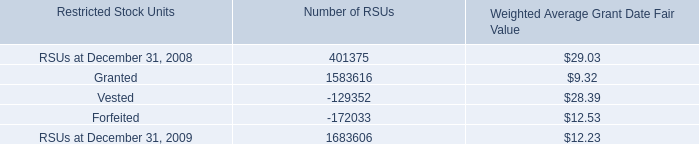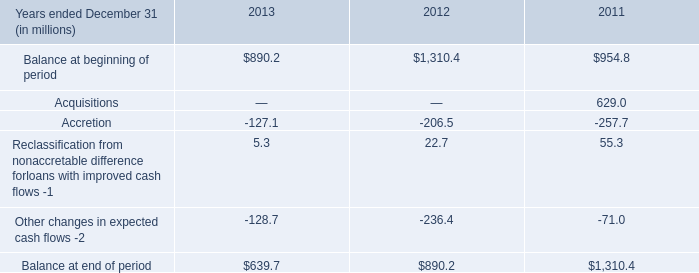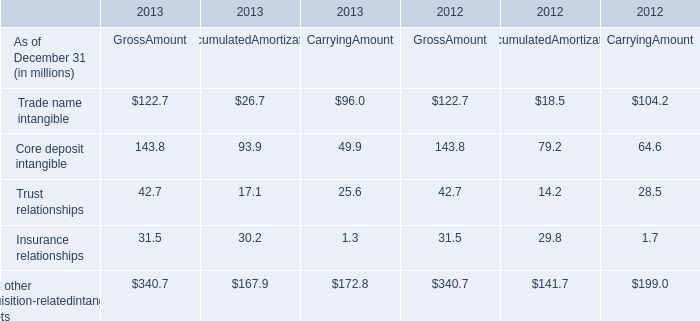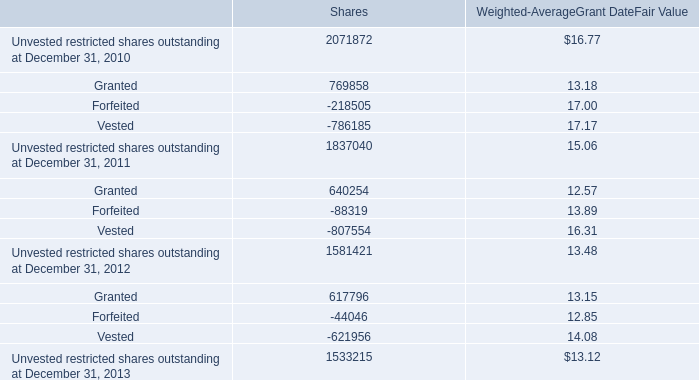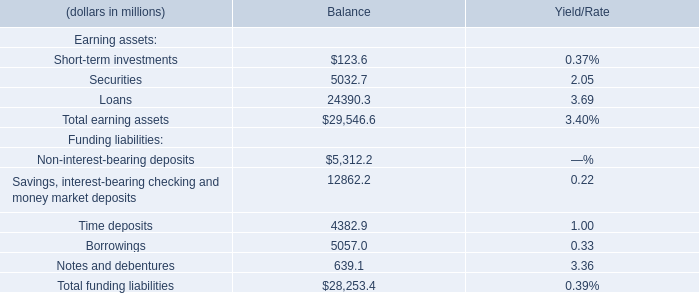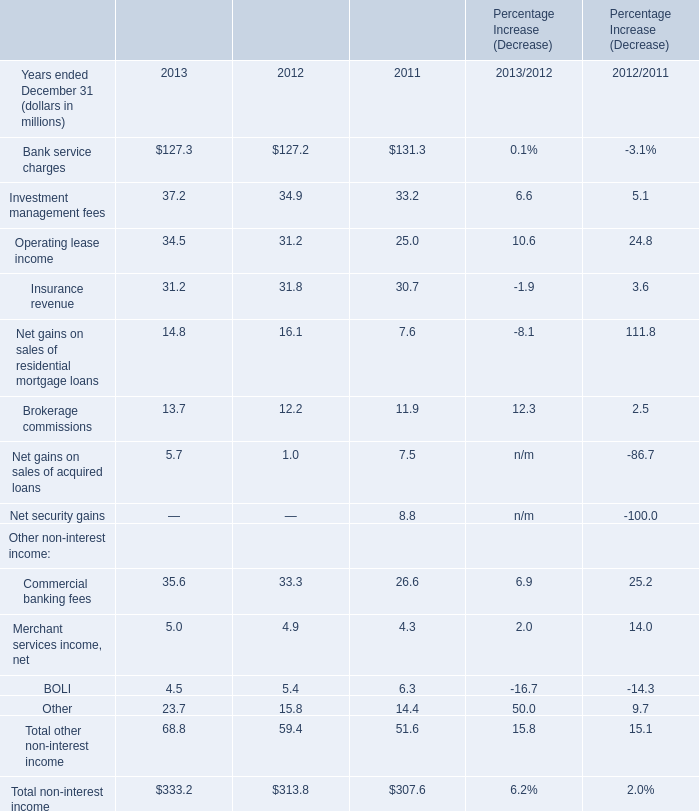In the year with largest amount of Commercial banking fees, what's the increasing rate of Merchant services income, net? (in %) 
Computations: ((5 - 4.9) / 4.9)
Answer: 0.02041. 